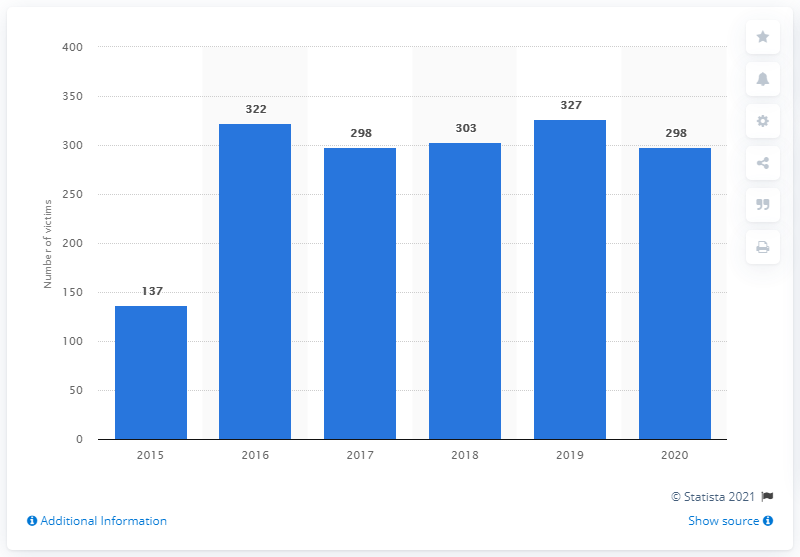Point out several critical features in this image. During the year 2020, a total of 298 femicides were classified in Argentina from January to December. In the year preceding the report, a total of 327 femicide victims were documented. 